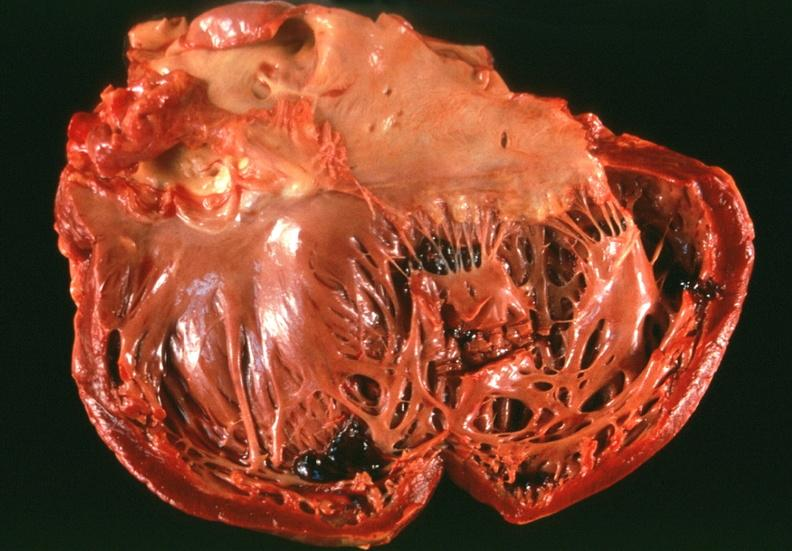what left ventricular dilatation?
Answer the question using a single word or phrase. Congestive heart failure, 